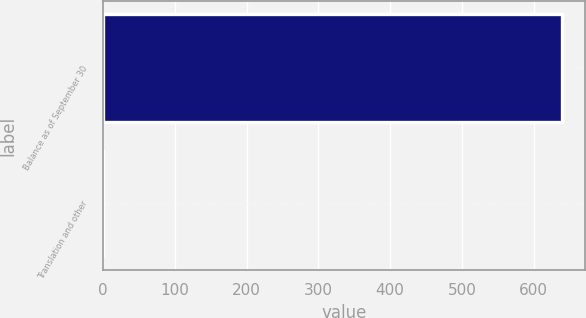<chart> <loc_0><loc_0><loc_500><loc_500><bar_chart><fcel>Balance as of September 30<fcel>Translation and other<nl><fcel>639.46<fcel>0.6<nl></chart> 